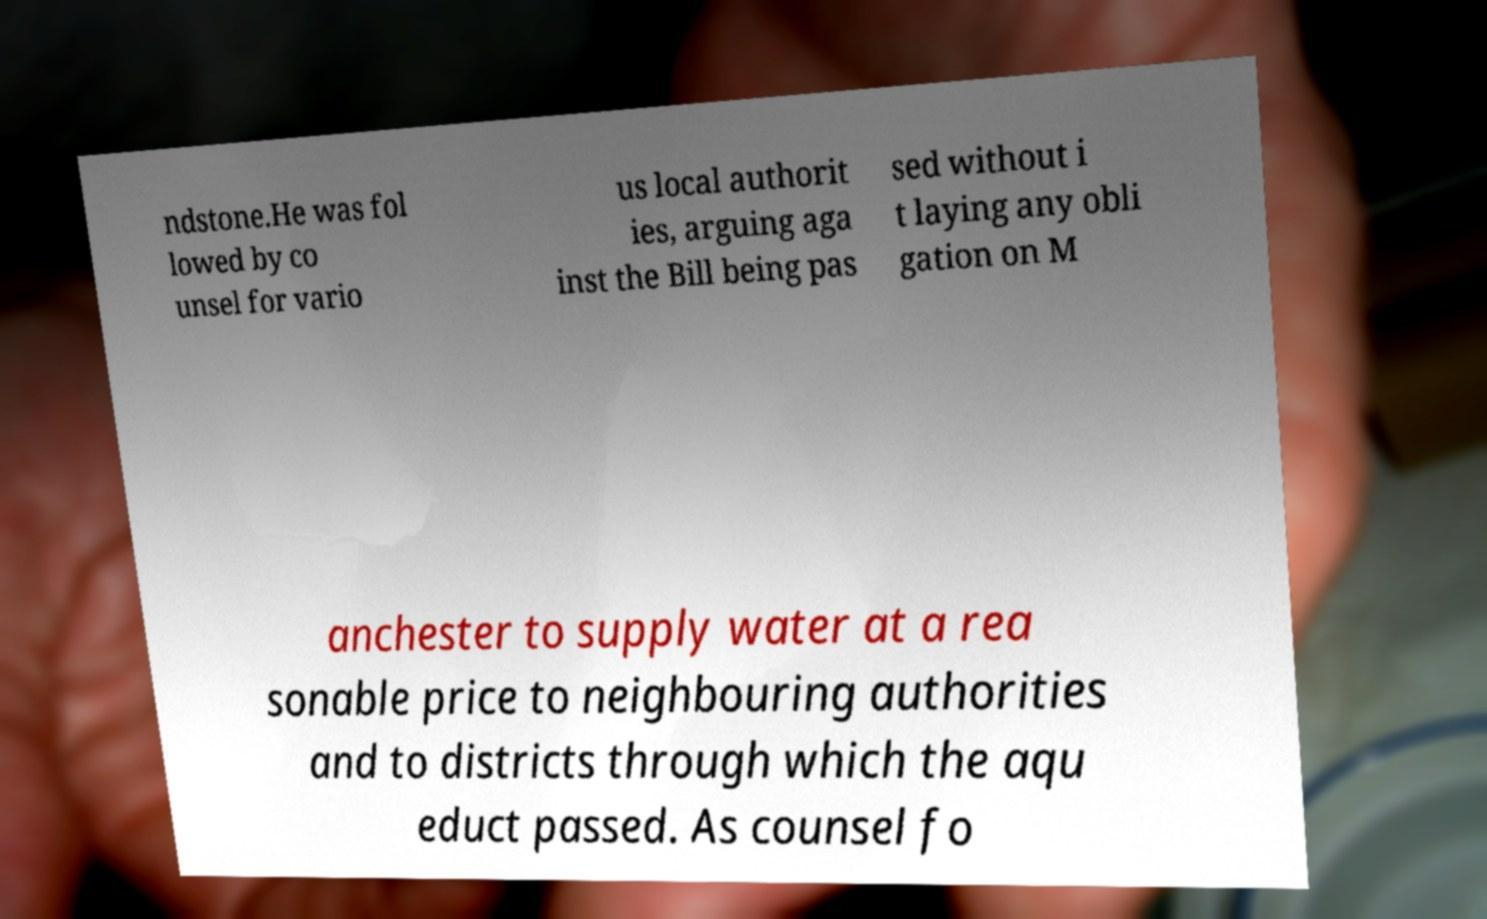Could you assist in decoding the text presented in this image and type it out clearly? ndstone.He was fol lowed by co unsel for vario us local authorit ies, arguing aga inst the Bill being pas sed without i t laying any obli gation on M anchester to supply water at a rea sonable price to neighbouring authorities and to districts through which the aqu educt passed. As counsel fo 